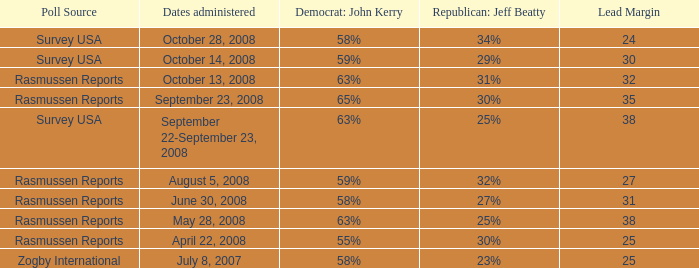Write the full table. {'header': ['Poll Source', 'Dates administered', 'Democrat: John Kerry', 'Republican: Jeff Beatty', 'Lead Margin'], 'rows': [['Survey USA', 'October 28, 2008', '58%', '34%', '24'], ['Survey USA', 'October 14, 2008', '59%', '29%', '30'], ['Rasmussen Reports', 'October 13, 2008', '63%', '31%', '32'], ['Rasmussen Reports', 'September 23, 2008', '65%', '30%', '35'], ['Survey USA', 'September 22-September 23, 2008', '63%', '25%', '38'], ['Rasmussen Reports', 'August 5, 2008', '59%', '32%', '27'], ['Rasmussen Reports', 'June 30, 2008', '58%', '27%', '31'], ['Rasmussen Reports', 'May 28, 2008', '63%', '25%', '38'], ['Rasmussen Reports', 'April 22, 2008', '55%', '30%', '25'], ['Zogby International', 'July 8, 2007', '58%', '23%', '25']]} From which poll provider does the information about republican jeff beatty having 27% support come? Rasmussen Reports. 